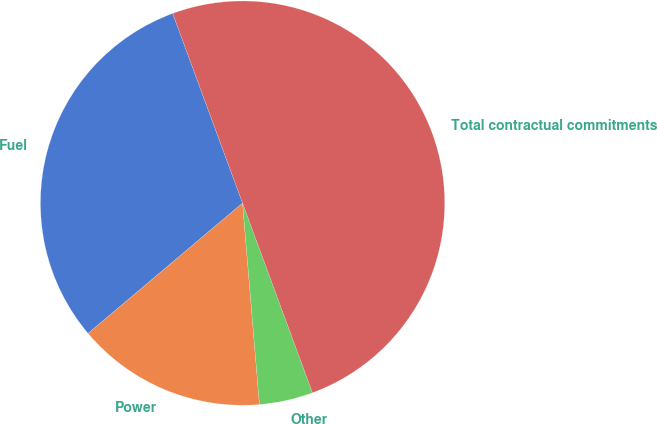Convert chart. <chart><loc_0><loc_0><loc_500><loc_500><pie_chart><fcel>Fuel<fcel>Power<fcel>Other<fcel>Total contractual commitments<nl><fcel>30.53%<fcel>15.18%<fcel>4.29%<fcel>50.0%<nl></chart> 